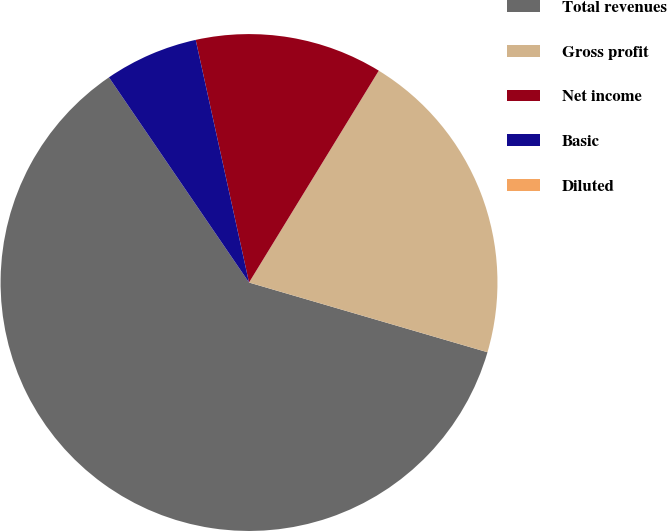<chart> <loc_0><loc_0><loc_500><loc_500><pie_chart><fcel>Total revenues<fcel>Gross profit<fcel>Net income<fcel>Basic<fcel>Diluted<nl><fcel>60.94%<fcel>20.78%<fcel>12.19%<fcel>6.09%<fcel>0.0%<nl></chart> 